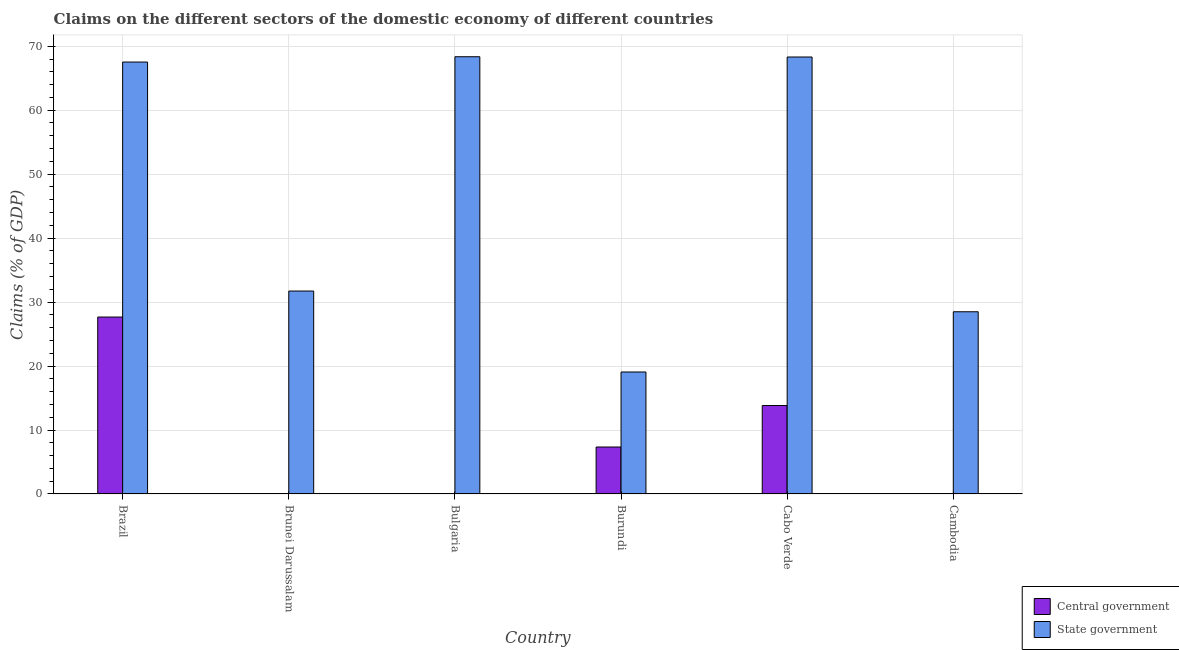How many different coloured bars are there?
Offer a very short reply. 2. Are the number of bars per tick equal to the number of legend labels?
Your response must be concise. No. What is the label of the 3rd group of bars from the left?
Provide a succinct answer. Bulgaria. In how many cases, is the number of bars for a given country not equal to the number of legend labels?
Give a very brief answer. 3. What is the claims on central government in Brazil?
Your answer should be compact. 27.66. Across all countries, what is the maximum claims on state government?
Offer a terse response. 68.36. What is the total claims on state government in the graph?
Keep it short and to the point. 283.49. What is the difference between the claims on state government in Brazil and that in Brunei Darussalam?
Your response must be concise. 35.8. What is the difference between the claims on state government in Bulgaria and the claims on central government in Cabo Verde?
Keep it short and to the point. 54.53. What is the average claims on state government per country?
Give a very brief answer. 47.25. What is the difference between the claims on central government and claims on state government in Burundi?
Offer a very short reply. -11.73. What is the ratio of the claims on state government in Bulgaria to that in Cabo Verde?
Provide a short and direct response. 1. What is the difference between the highest and the second highest claims on central government?
Your answer should be compact. 13.83. What is the difference between the highest and the lowest claims on central government?
Your response must be concise. 27.66. Is the sum of the claims on state government in Brazil and Burundi greater than the maximum claims on central government across all countries?
Your answer should be compact. Yes. How many countries are there in the graph?
Provide a short and direct response. 6. What is the difference between two consecutive major ticks on the Y-axis?
Provide a succinct answer. 10. Are the values on the major ticks of Y-axis written in scientific E-notation?
Your response must be concise. No. Does the graph contain grids?
Keep it short and to the point. Yes. How are the legend labels stacked?
Ensure brevity in your answer.  Vertical. What is the title of the graph?
Provide a succinct answer. Claims on the different sectors of the domestic economy of different countries. What is the label or title of the Y-axis?
Give a very brief answer. Claims (% of GDP). What is the Claims (% of GDP) in Central government in Brazil?
Provide a succinct answer. 27.66. What is the Claims (% of GDP) in State government in Brazil?
Your response must be concise. 67.53. What is the Claims (% of GDP) in Central government in Brunei Darussalam?
Your answer should be very brief. 0. What is the Claims (% of GDP) in State government in Brunei Darussalam?
Your response must be concise. 31.73. What is the Claims (% of GDP) in Central government in Bulgaria?
Your response must be concise. 0. What is the Claims (% of GDP) in State government in Bulgaria?
Offer a very short reply. 68.36. What is the Claims (% of GDP) of Central government in Burundi?
Provide a short and direct response. 7.34. What is the Claims (% of GDP) in State government in Burundi?
Give a very brief answer. 19.07. What is the Claims (% of GDP) in Central government in Cabo Verde?
Offer a very short reply. 13.83. What is the Claims (% of GDP) of State government in Cabo Verde?
Provide a short and direct response. 68.32. What is the Claims (% of GDP) of Central government in Cambodia?
Ensure brevity in your answer.  0. What is the Claims (% of GDP) in State government in Cambodia?
Make the answer very short. 28.49. Across all countries, what is the maximum Claims (% of GDP) in Central government?
Your response must be concise. 27.66. Across all countries, what is the maximum Claims (% of GDP) of State government?
Make the answer very short. 68.36. Across all countries, what is the minimum Claims (% of GDP) of Central government?
Offer a very short reply. 0. Across all countries, what is the minimum Claims (% of GDP) of State government?
Keep it short and to the point. 19.07. What is the total Claims (% of GDP) in Central government in the graph?
Keep it short and to the point. 48.83. What is the total Claims (% of GDP) of State government in the graph?
Ensure brevity in your answer.  283.49. What is the difference between the Claims (% of GDP) of State government in Brazil and that in Brunei Darussalam?
Provide a succinct answer. 35.8. What is the difference between the Claims (% of GDP) of State government in Brazil and that in Bulgaria?
Keep it short and to the point. -0.83. What is the difference between the Claims (% of GDP) of Central government in Brazil and that in Burundi?
Your answer should be very brief. 20.32. What is the difference between the Claims (% of GDP) of State government in Brazil and that in Burundi?
Ensure brevity in your answer.  48.46. What is the difference between the Claims (% of GDP) in Central government in Brazil and that in Cabo Verde?
Offer a very short reply. 13.83. What is the difference between the Claims (% of GDP) of State government in Brazil and that in Cabo Verde?
Offer a very short reply. -0.79. What is the difference between the Claims (% of GDP) in State government in Brazil and that in Cambodia?
Make the answer very short. 39.04. What is the difference between the Claims (% of GDP) of State government in Brunei Darussalam and that in Bulgaria?
Keep it short and to the point. -36.63. What is the difference between the Claims (% of GDP) in State government in Brunei Darussalam and that in Burundi?
Offer a terse response. 12.66. What is the difference between the Claims (% of GDP) in State government in Brunei Darussalam and that in Cabo Verde?
Your answer should be very brief. -36.59. What is the difference between the Claims (% of GDP) in State government in Brunei Darussalam and that in Cambodia?
Provide a succinct answer. 3.24. What is the difference between the Claims (% of GDP) in State government in Bulgaria and that in Burundi?
Keep it short and to the point. 49.29. What is the difference between the Claims (% of GDP) of State government in Bulgaria and that in Cabo Verde?
Provide a succinct answer. 0.04. What is the difference between the Claims (% of GDP) in State government in Bulgaria and that in Cambodia?
Make the answer very short. 39.87. What is the difference between the Claims (% of GDP) of Central government in Burundi and that in Cabo Verde?
Offer a very short reply. -6.49. What is the difference between the Claims (% of GDP) in State government in Burundi and that in Cabo Verde?
Offer a very short reply. -49.25. What is the difference between the Claims (% of GDP) in State government in Burundi and that in Cambodia?
Keep it short and to the point. -9.42. What is the difference between the Claims (% of GDP) in State government in Cabo Verde and that in Cambodia?
Your response must be concise. 39.83. What is the difference between the Claims (% of GDP) in Central government in Brazil and the Claims (% of GDP) in State government in Brunei Darussalam?
Provide a succinct answer. -4.07. What is the difference between the Claims (% of GDP) of Central government in Brazil and the Claims (% of GDP) of State government in Bulgaria?
Give a very brief answer. -40.7. What is the difference between the Claims (% of GDP) in Central government in Brazil and the Claims (% of GDP) in State government in Burundi?
Ensure brevity in your answer.  8.59. What is the difference between the Claims (% of GDP) in Central government in Brazil and the Claims (% of GDP) in State government in Cabo Verde?
Your answer should be compact. -40.66. What is the difference between the Claims (% of GDP) in Central government in Brazil and the Claims (% of GDP) in State government in Cambodia?
Keep it short and to the point. -0.83. What is the difference between the Claims (% of GDP) in Central government in Burundi and the Claims (% of GDP) in State government in Cabo Verde?
Your answer should be compact. -60.97. What is the difference between the Claims (% of GDP) of Central government in Burundi and the Claims (% of GDP) of State government in Cambodia?
Your answer should be very brief. -21.14. What is the difference between the Claims (% of GDP) of Central government in Cabo Verde and the Claims (% of GDP) of State government in Cambodia?
Your answer should be very brief. -14.66. What is the average Claims (% of GDP) of Central government per country?
Your response must be concise. 8.14. What is the average Claims (% of GDP) of State government per country?
Ensure brevity in your answer.  47.25. What is the difference between the Claims (% of GDP) of Central government and Claims (% of GDP) of State government in Brazil?
Offer a terse response. -39.87. What is the difference between the Claims (% of GDP) in Central government and Claims (% of GDP) in State government in Burundi?
Keep it short and to the point. -11.73. What is the difference between the Claims (% of GDP) of Central government and Claims (% of GDP) of State government in Cabo Verde?
Your answer should be very brief. -54.49. What is the ratio of the Claims (% of GDP) in State government in Brazil to that in Brunei Darussalam?
Keep it short and to the point. 2.13. What is the ratio of the Claims (% of GDP) in State government in Brazil to that in Bulgaria?
Provide a short and direct response. 0.99. What is the ratio of the Claims (% of GDP) in Central government in Brazil to that in Burundi?
Offer a terse response. 3.77. What is the ratio of the Claims (% of GDP) of State government in Brazil to that in Burundi?
Make the answer very short. 3.54. What is the ratio of the Claims (% of GDP) of Central government in Brazil to that in Cabo Verde?
Offer a very short reply. 2. What is the ratio of the Claims (% of GDP) in State government in Brazil to that in Cabo Verde?
Make the answer very short. 0.99. What is the ratio of the Claims (% of GDP) in State government in Brazil to that in Cambodia?
Provide a succinct answer. 2.37. What is the ratio of the Claims (% of GDP) in State government in Brunei Darussalam to that in Bulgaria?
Ensure brevity in your answer.  0.46. What is the ratio of the Claims (% of GDP) of State government in Brunei Darussalam to that in Burundi?
Offer a terse response. 1.66. What is the ratio of the Claims (% of GDP) in State government in Brunei Darussalam to that in Cabo Verde?
Your response must be concise. 0.46. What is the ratio of the Claims (% of GDP) of State government in Brunei Darussalam to that in Cambodia?
Provide a succinct answer. 1.11. What is the ratio of the Claims (% of GDP) in State government in Bulgaria to that in Burundi?
Keep it short and to the point. 3.58. What is the ratio of the Claims (% of GDP) in State government in Bulgaria to that in Cambodia?
Offer a terse response. 2.4. What is the ratio of the Claims (% of GDP) in Central government in Burundi to that in Cabo Verde?
Your answer should be compact. 0.53. What is the ratio of the Claims (% of GDP) in State government in Burundi to that in Cabo Verde?
Offer a terse response. 0.28. What is the ratio of the Claims (% of GDP) of State government in Burundi to that in Cambodia?
Offer a very short reply. 0.67. What is the ratio of the Claims (% of GDP) of State government in Cabo Verde to that in Cambodia?
Offer a very short reply. 2.4. What is the difference between the highest and the second highest Claims (% of GDP) in Central government?
Keep it short and to the point. 13.83. What is the difference between the highest and the second highest Claims (% of GDP) in State government?
Offer a terse response. 0.04. What is the difference between the highest and the lowest Claims (% of GDP) in Central government?
Keep it short and to the point. 27.66. What is the difference between the highest and the lowest Claims (% of GDP) in State government?
Your response must be concise. 49.29. 